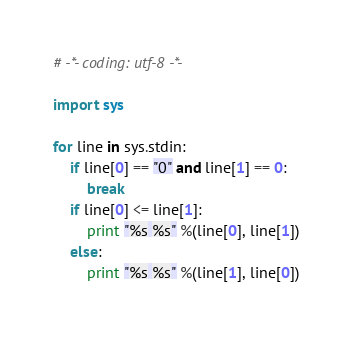Convert code to text. <code><loc_0><loc_0><loc_500><loc_500><_Python_># -*- coding: utf-8 -*-

import sys

for line in sys.stdin:
    if line[0] == "0" and line[1] == 0:
        break
    if line[0] <= line[1]:
        print "%s %s" %(line[0], line[1])
    else:
        print "%s %s" %(line[1], line[0])</code> 